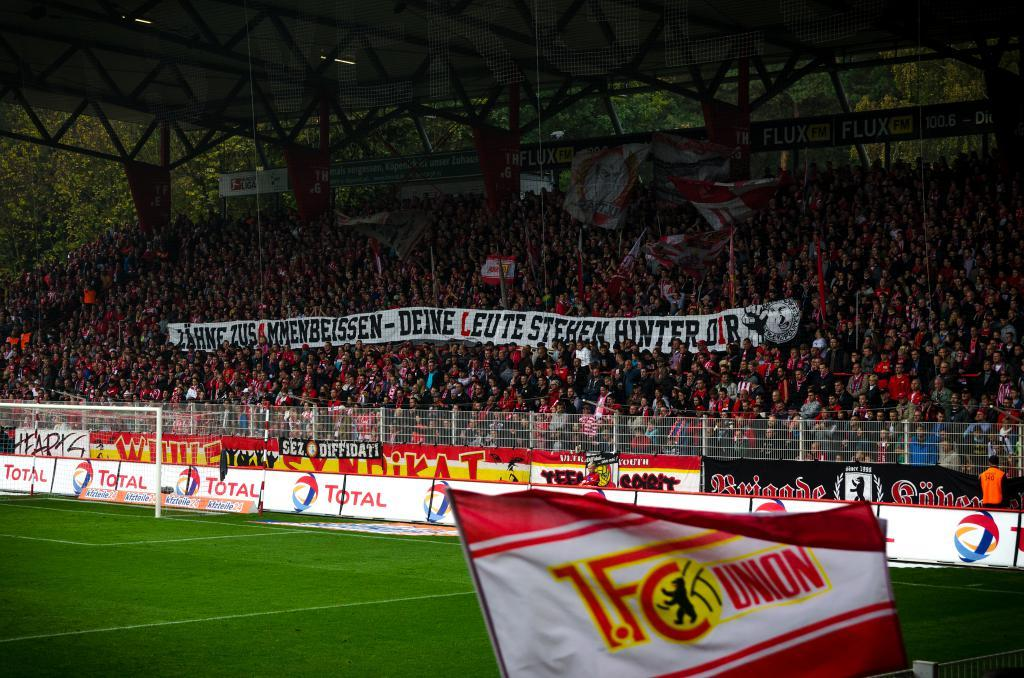What can be seen at the bottom of the image? The ground is visible in the image. What is located in the background of the image? There are people in the background of the image. What object in the image has text written on it? There is a board with text written on it in the image. How many apples are on the calculator in the image? There is no calculator or apples present in the image. What type of cars can be seen driving in the background of the image? There are no cars visible in the background of the image. 